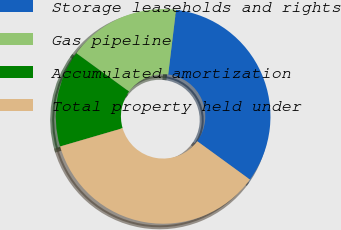Convert chart. <chart><loc_0><loc_0><loc_500><loc_500><pie_chart><fcel>Storage leaseholds and rights<fcel>Gas pipeline<fcel>Accumulated amortization<fcel>Total property held under<nl><fcel>33.09%<fcel>16.91%<fcel>14.54%<fcel>35.46%<nl></chart> 